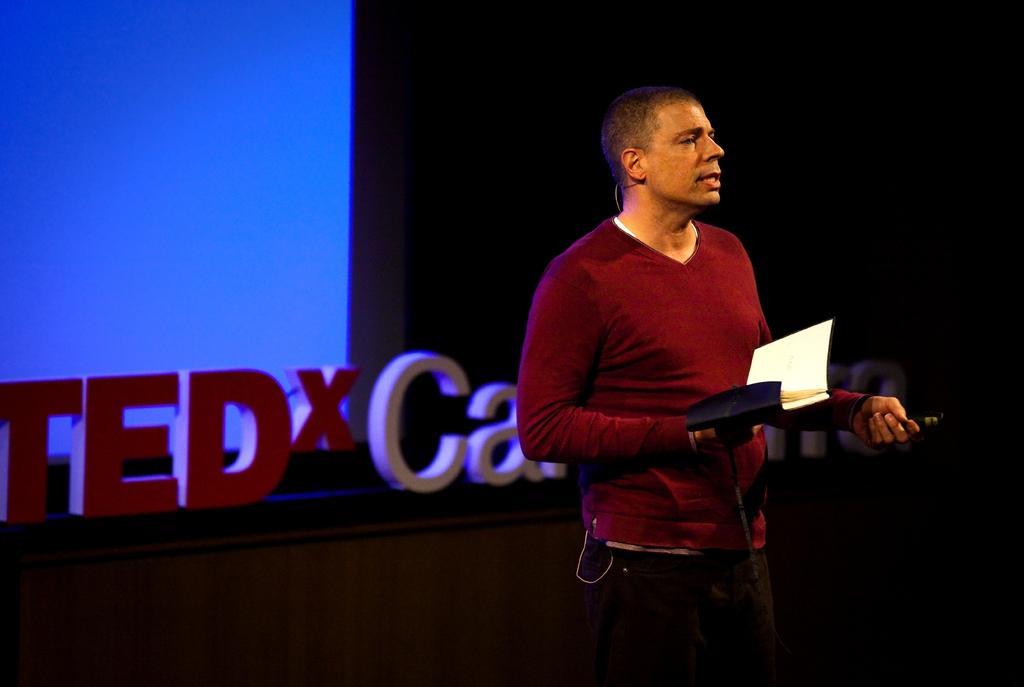In one or two sentences, can you explain what this image depicts? In this image I see a man who is wearing red t-shirt and jeans and I see he is holding a book in his hand. In the background I see few words over here and I see a blue color thing over here and it is dark over here. 